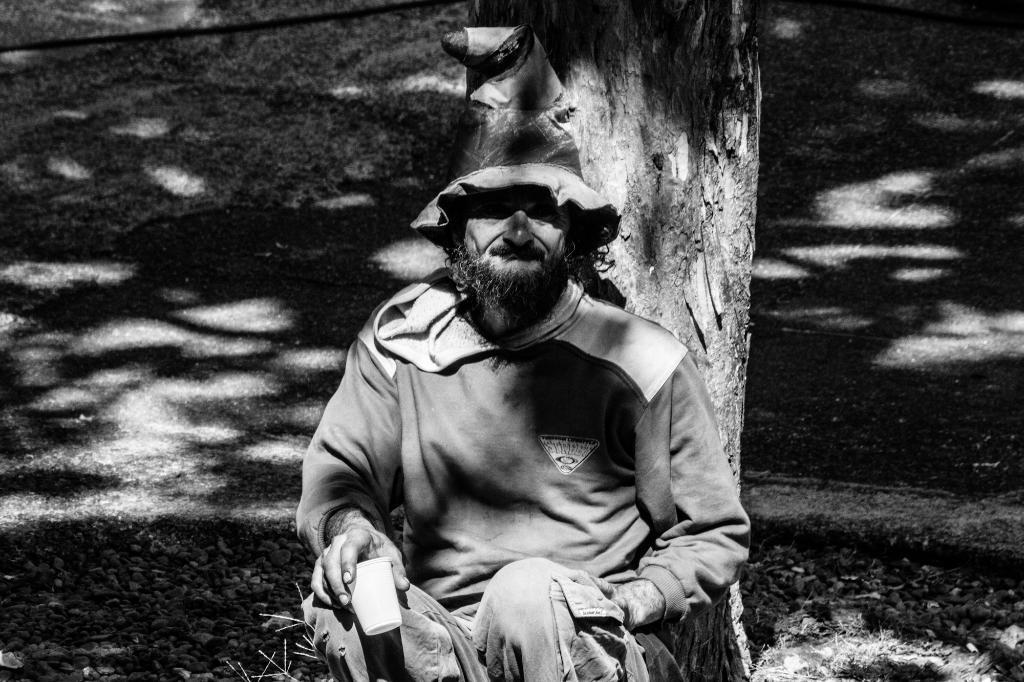What is the color scheme of the image? The image is black and white. Who is present in the image? There is a man in the image. What is the man wearing on his head? The man is wearing a hat. What is the man holding in the image? The man is holding a cup. What can be seen in the background of the image? There is a tree trunk visible in the background of the image. What type of ornament is hanging from the tree trunk in the image? There is no ornament hanging from the tree trunk in the image; it only shows a tree trunk in the background. Can you tell me how far the ocean is from the man in the image? There is no ocean visible in the image, so it is not possible to determine its distance from the man. 